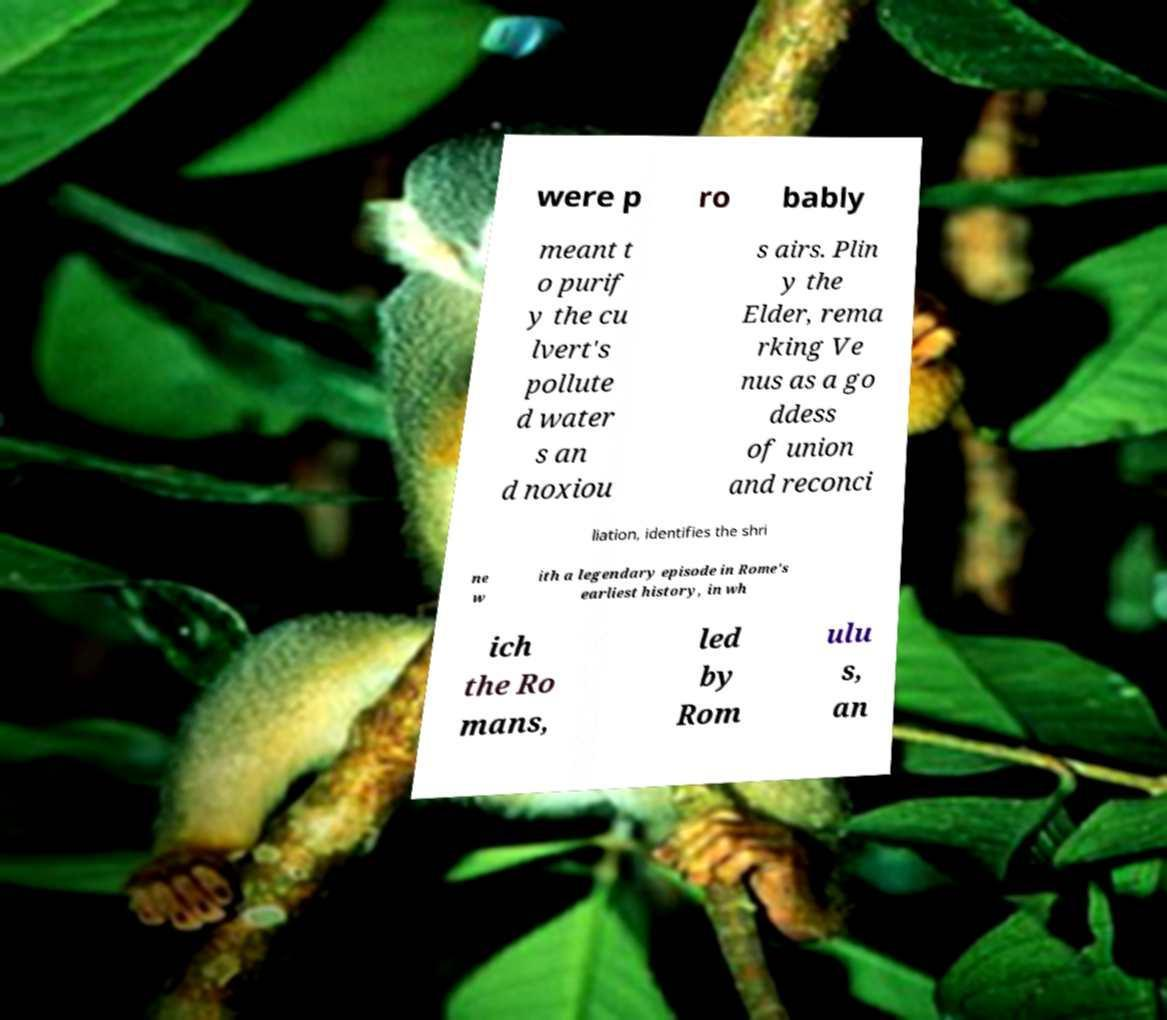For documentation purposes, I need the text within this image transcribed. Could you provide that? were p ro bably meant t o purif y the cu lvert's pollute d water s an d noxiou s airs. Plin y the Elder, rema rking Ve nus as a go ddess of union and reconci liation, identifies the shri ne w ith a legendary episode in Rome's earliest history, in wh ich the Ro mans, led by Rom ulu s, an 